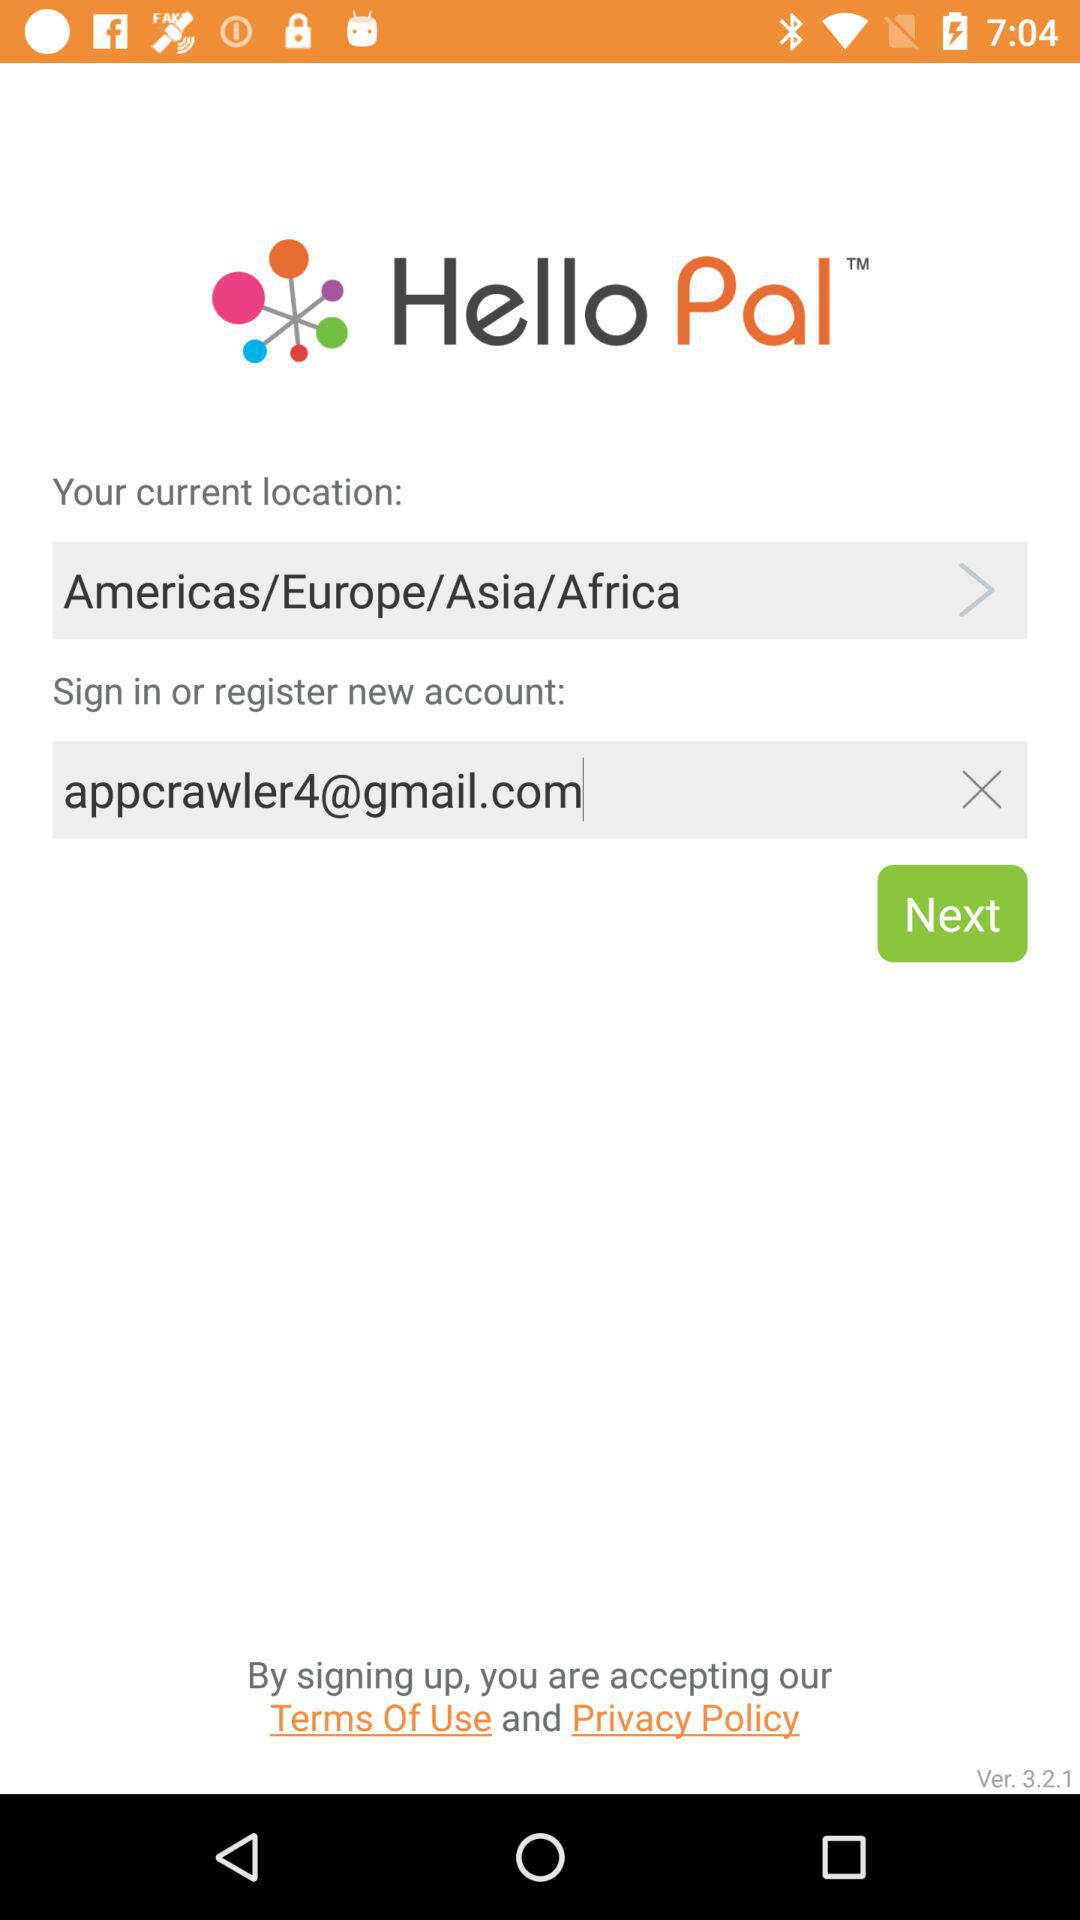Which state does the user live in?
When the provided information is insufficient, respond with <no answer>. <no answer> 